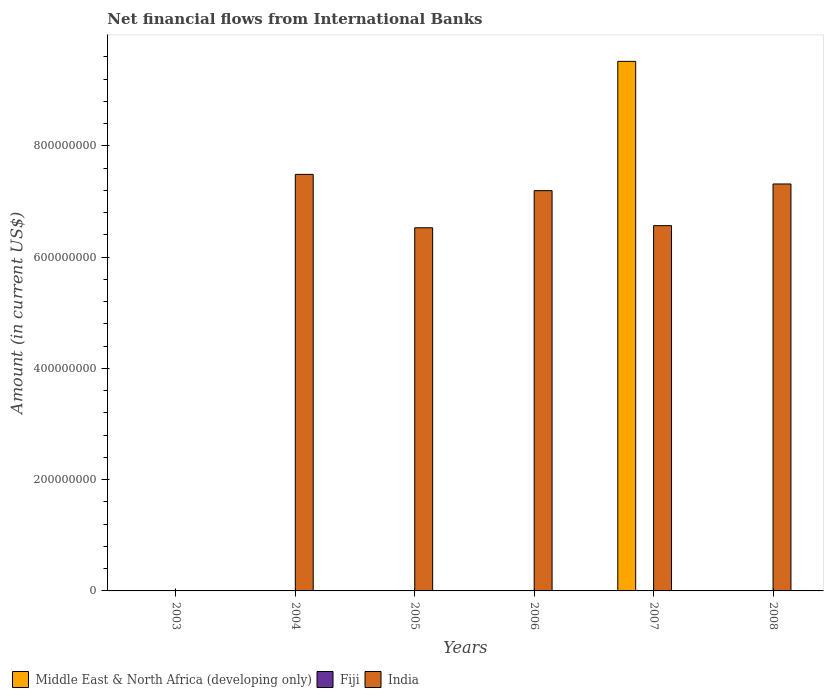How many different coloured bars are there?
Give a very brief answer. 2. How many bars are there on the 1st tick from the left?
Provide a short and direct response. 0. In how many cases, is the number of bars for a given year not equal to the number of legend labels?
Your answer should be compact. 6. What is the net financial aid flows in India in 2007?
Offer a very short reply. 6.57e+08. Across all years, what is the maximum net financial aid flows in India?
Offer a very short reply. 7.49e+08. Across all years, what is the minimum net financial aid flows in Fiji?
Your answer should be compact. 0. What is the difference between the net financial aid flows in India in 2005 and that in 2007?
Offer a very short reply. -3.83e+06. What is the difference between the net financial aid flows in Middle East & North Africa (developing only) in 2007 and the net financial aid flows in Fiji in 2003?
Make the answer very short. 9.52e+08. What is the average net financial aid flows in India per year?
Keep it short and to the point. 5.85e+08. What is the ratio of the net financial aid flows in India in 2004 to that in 2005?
Offer a terse response. 1.15. What is the difference between the highest and the second highest net financial aid flows in India?
Offer a very short reply. 1.73e+07. What is the difference between the highest and the lowest net financial aid flows in India?
Ensure brevity in your answer.  7.49e+08. Is it the case that in every year, the sum of the net financial aid flows in Middle East & North Africa (developing only) and net financial aid flows in Fiji is greater than the net financial aid flows in India?
Your answer should be compact. No. How many bars are there?
Your answer should be compact. 6. Are all the bars in the graph horizontal?
Your response must be concise. No. How many years are there in the graph?
Offer a terse response. 6. What is the difference between two consecutive major ticks on the Y-axis?
Offer a terse response. 2.00e+08. Are the values on the major ticks of Y-axis written in scientific E-notation?
Provide a short and direct response. No. What is the title of the graph?
Keep it short and to the point. Net financial flows from International Banks. Does "Uzbekistan" appear as one of the legend labels in the graph?
Your answer should be very brief. No. What is the label or title of the X-axis?
Offer a terse response. Years. What is the label or title of the Y-axis?
Make the answer very short. Amount (in current US$). What is the Amount (in current US$) of Middle East & North Africa (developing only) in 2003?
Provide a short and direct response. 0. What is the Amount (in current US$) in Fiji in 2003?
Your response must be concise. 0. What is the Amount (in current US$) of India in 2003?
Provide a succinct answer. 0. What is the Amount (in current US$) of India in 2004?
Provide a succinct answer. 7.49e+08. What is the Amount (in current US$) in Fiji in 2005?
Offer a very short reply. 0. What is the Amount (in current US$) in India in 2005?
Ensure brevity in your answer.  6.53e+08. What is the Amount (in current US$) in Fiji in 2006?
Offer a very short reply. 0. What is the Amount (in current US$) in India in 2006?
Your answer should be very brief. 7.20e+08. What is the Amount (in current US$) in Middle East & North Africa (developing only) in 2007?
Offer a terse response. 9.52e+08. What is the Amount (in current US$) in Fiji in 2007?
Offer a terse response. 0. What is the Amount (in current US$) of India in 2007?
Provide a short and direct response. 6.57e+08. What is the Amount (in current US$) of Middle East & North Africa (developing only) in 2008?
Make the answer very short. 0. What is the Amount (in current US$) in India in 2008?
Provide a succinct answer. 7.32e+08. Across all years, what is the maximum Amount (in current US$) of Middle East & North Africa (developing only)?
Keep it short and to the point. 9.52e+08. Across all years, what is the maximum Amount (in current US$) of India?
Provide a short and direct response. 7.49e+08. What is the total Amount (in current US$) in Middle East & North Africa (developing only) in the graph?
Your answer should be very brief. 9.52e+08. What is the total Amount (in current US$) in India in the graph?
Your response must be concise. 3.51e+09. What is the difference between the Amount (in current US$) in India in 2004 and that in 2005?
Give a very brief answer. 9.60e+07. What is the difference between the Amount (in current US$) of India in 2004 and that in 2006?
Offer a very short reply. 2.93e+07. What is the difference between the Amount (in current US$) in India in 2004 and that in 2007?
Provide a succinct answer. 9.22e+07. What is the difference between the Amount (in current US$) in India in 2004 and that in 2008?
Keep it short and to the point. 1.73e+07. What is the difference between the Amount (in current US$) of India in 2005 and that in 2006?
Give a very brief answer. -6.67e+07. What is the difference between the Amount (in current US$) in India in 2005 and that in 2007?
Keep it short and to the point. -3.83e+06. What is the difference between the Amount (in current US$) in India in 2005 and that in 2008?
Your answer should be compact. -7.87e+07. What is the difference between the Amount (in current US$) in India in 2006 and that in 2007?
Provide a succinct answer. 6.29e+07. What is the difference between the Amount (in current US$) of India in 2006 and that in 2008?
Provide a short and direct response. -1.20e+07. What is the difference between the Amount (in current US$) of India in 2007 and that in 2008?
Give a very brief answer. -7.49e+07. What is the difference between the Amount (in current US$) in Middle East & North Africa (developing only) in 2007 and the Amount (in current US$) in India in 2008?
Offer a terse response. 2.20e+08. What is the average Amount (in current US$) in Middle East & North Africa (developing only) per year?
Provide a short and direct response. 1.59e+08. What is the average Amount (in current US$) of Fiji per year?
Your answer should be very brief. 0. What is the average Amount (in current US$) in India per year?
Your answer should be very brief. 5.85e+08. In the year 2007, what is the difference between the Amount (in current US$) of Middle East & North Africa (developing only) and Amount (in current US$) of India?
Give a very brief answer. 2.95e+08. What is the ratio of the Amount (in current US$) in India in 2004 to that in 2005?
Your answer should be compact. 1.15. What is the ratio of the Amount (in current US$) in India in 2004 to that in 2006?
Your response must be concise. 1.04. What is the ratio of the Amount (in current US$) of India in 2004 to that in 2007?
Give a very brief answer. 1.14. What is the ratio of the Amount (in current US$) of India in 2004 to that in 2008?
Your answer should be compact. 1.02. What is the ratio of the Amount (in current US$) of India in 2005 to that in 2006?
Provide a short and direct response. 0.91. What is the ratio of the Amount (in current US$) of India in 2005 to that in 2008?
Offer a very short reply. 0.89. What is the ratio of the Amount (in current US$) of India in 2006 to that in 2007?
Offer a very short reply. 1.1. What is the ratio of the Amount (in current US$) of India in 2006 to that in 2008?
Offer a terse response. 0.98. What is the ratio of the Amount (in current US$) of India in 2007 to that in 2008?
Make the answer very short. 0.9. What is the difference between the highest and the second highest Amount (in current US$) in India?
Ensure brevity in your answer.  1.73e+07. What is the difference between the highest and the lowest Amount (in current US$) of Middle East & North Africa (developing only)?
Provide a succinct answer. 9.52e+08. What is the difference between the highest and the lowest Amount (in current US$) in India?
Offer a terse response. 7.49e+08. 